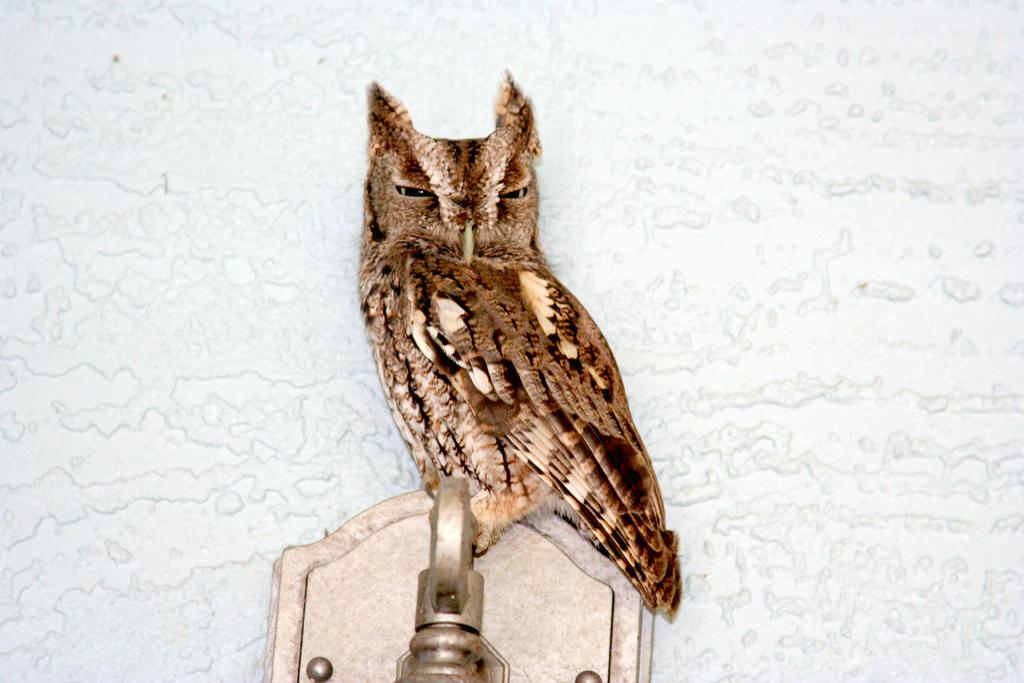What animal is present in the image? There is an owl in the image. Where is the owl located? The owl is on a metal rod. What can be seen in the background of the image? There is a wall in the background of the image. Can you describe the possible setting of the image? The image may have been taken in a hall. How many sisters are present in the image? There are no sisters present in the image; it features an owl on a metal rod with a wall in the background. 